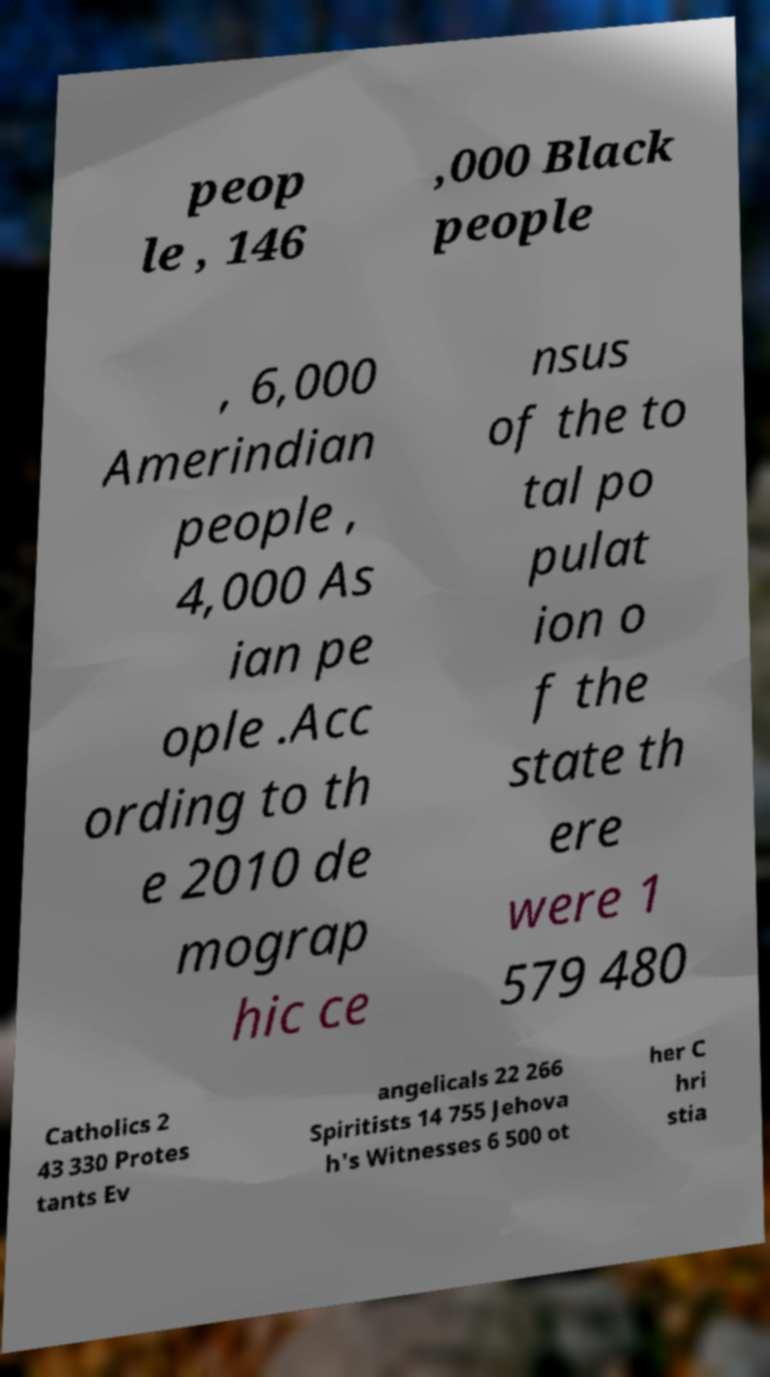For documentation purposes, I need the text within this image transcribed. Could you provide that? peop le , 146 ,000 Black people , 6,000 Amerindian people , 4,000 As ian pe ople .Acc ording to th e 2010 de mograp hic ce nsus of the to tal po pulat ion o f the state th ere were 1 579 480 Catholics 2 43 330 Protes tants Ev angelicals 22 266 Spiritists 14 755 Jehova h's Witnesses 6 500 ot her C hri stia 